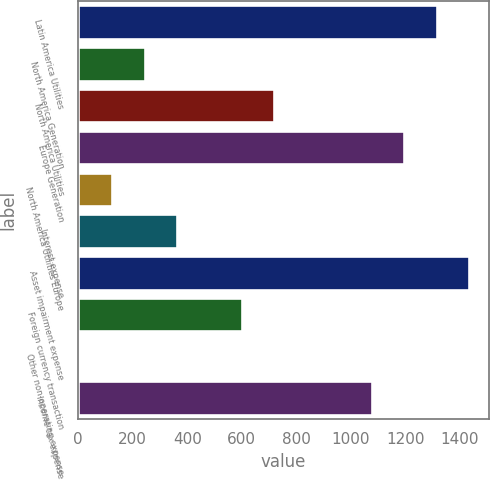Convert chart. <chart><loc_0><loc_0><loc_500><loc_500><bar_chart><fcel>Latin America Utilities<fcel>North America Generation<fcel>North America Utilities<fcel>Europe Generation<fcel>North America Utilities Europe<fcel>Interest expense<fcel>Asset impairment expense<fcel>Foreign currency transaction<fcel>Other non-operating expense<fcel>Income tax expense<nl><fcel>1315.1<fcel>243.2<fcel>719.6<fcel>1196<fcel>124.1<fcel>362.3<fcel>1434.2<fcel>600.5<fcel>5<fcel>1076.9<nl></chart> 